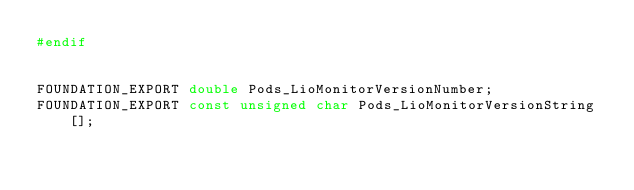<code> <loc_0><loc_0><loc_500><loc_500><_C_>#endif


FOUNDATION_EXPORT double Pods_LioMonitorVersionNumber;
FOUNDATION_EXPORT const unsigned char Pods_LioMonitorVersionString[];

</code> 